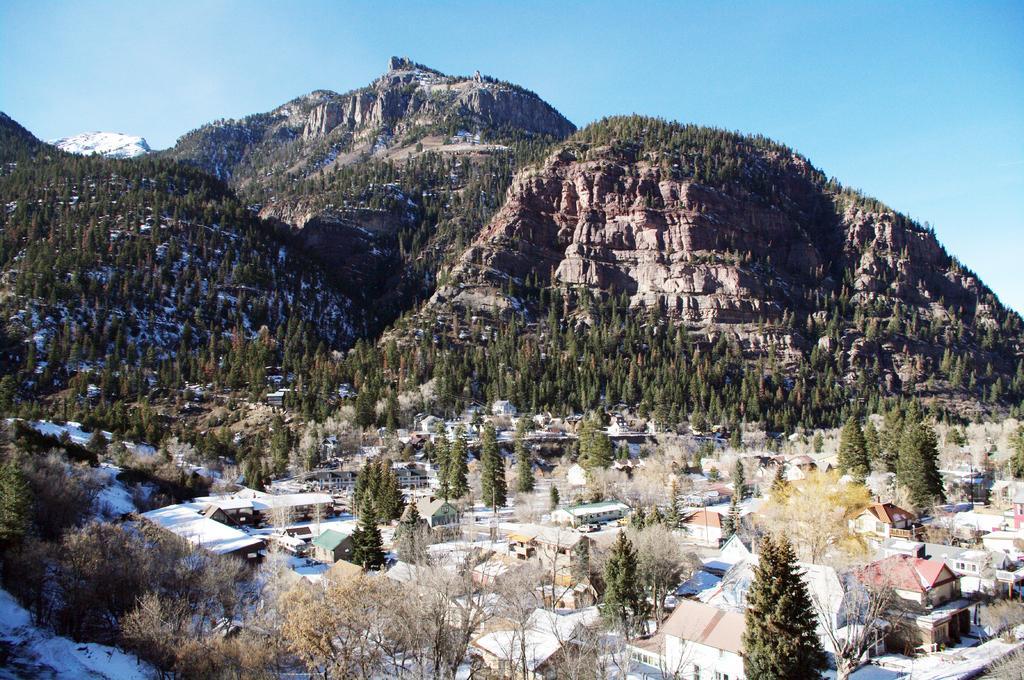Could you give a brief overview of what you see in this image? In this image, we can see a mountains, trees, houses, poles. Left side bottom, there is a snow. Top of the image, there is a clear sky. 